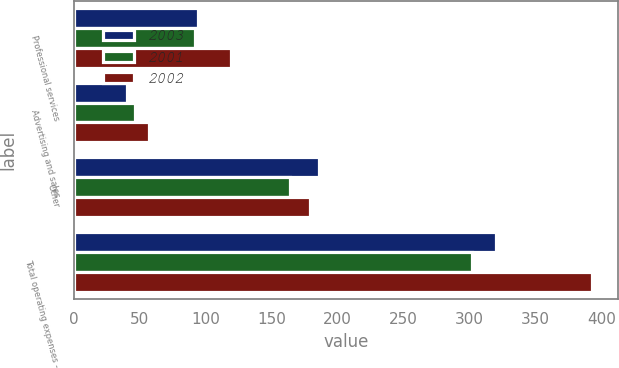Convert chart to OTSL. <chart><loc_0><loc_0><loc_500><loc_500><stacked_bar_chart><ecel><fcel>Professional services<fcel>Advertising and sales<fcel>Other<fcel>Total operating expenses -<nl><fcel>2003<fcel>94<fcel>40<fcel>186<fcel>320<nl><fcel>2001<fcel>92<fcel>46<fcel>164<fcel>302<nl><fcel>2002<fcel>119<fcel>57<fcel>179<fcel>393<nl></chart> 